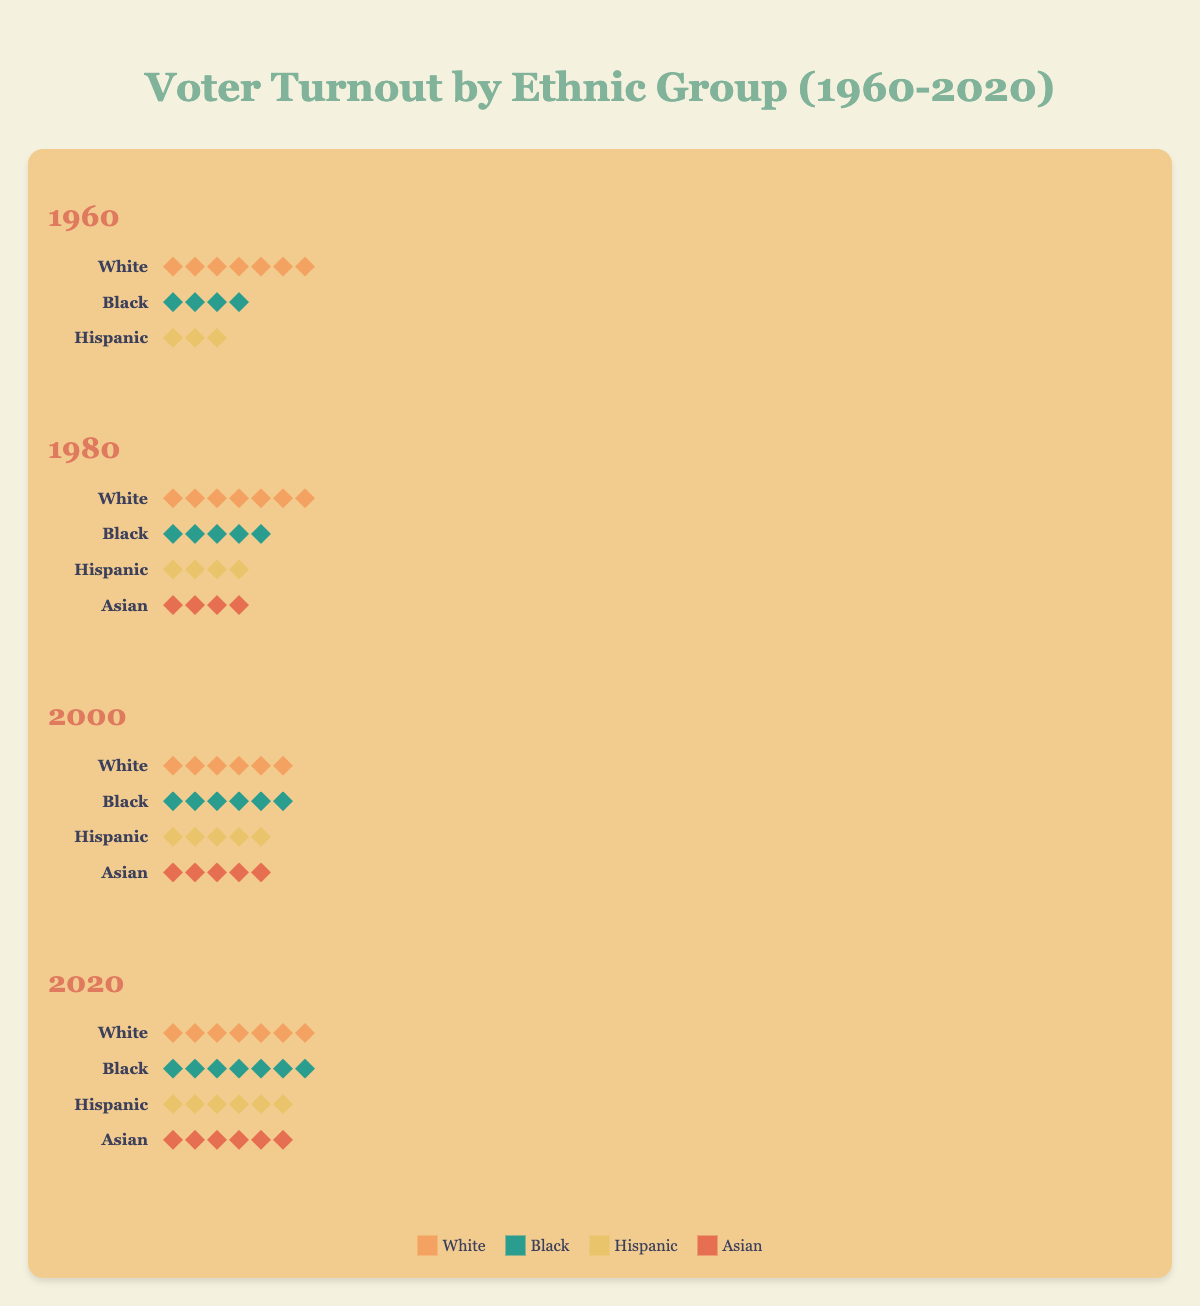What is the overall trend of voter turnout for the White group from 1960 to 2020? The voter turnout for the White group starts at 70% in 1960, decreases to 65% in 1980 and further down to 60% in 2000, then increases back to 70% in 2020.
Answer: Fluctuating with a final increase Which ethnic group had the lowest voter turnout in 1960? By looking at the number of icons representing votes in 1960, the Hispanic group had the lowest turnout with only 3 icons representing 30%.
Answer: Hispanic How many percentage points did the voter turnout for the Black group increase from 1980 to 2020? The turnout increased from 50% in 1980 to 65% in 2020. Calculating the difference: 65% - 50% = 15%.
Answer: 15% What is the difference in voter turnout between the Hispanic and Asian groups in 2020? In 2020, Hispanic turnout was 55% and Asian turnout was 60%. The difference is 60% - 55% = 5%.
Answer: 5% Which group had the highest voter turnout in 2000? Observing the icons for 2000, the White group had the highest turnout with 60% reflected through 6 icons.
Answer: White How did the voter turnout for the Black group change from 1960 to 2000? The Black group’s turnout increased from 40% in 1960 to 50% in 1980 and then further to 55% in 2000.
Answer: Increased How much did the Hispanic voter turnout increase from 1960 to 2020 in terms of percentage? The turnout for Hispanic voters was 30% in 1960 and rose to 55% in 2020. Calculating the increase: 55% - 30% = 25%.
Answer: 25% In which election year did the Asian group first appear, and what was their turnout? The Asian group first appeared in the 1980 election with a voter turnout rate of 40%.
Answer: 1980, 40% What's the total percentage of voter turnout combined for the Asian and Hispanic groups in 2000? Adding the turnout percentages for the Asian (45%) and Hispanic (45%) groups in 2000, we get a total of 45% + 45% = 90%.
Answer: 90% Which group made the most significant gain in voter turnout from 1960 to 2020? By analyzing the changes, the Black group’s turnout increased significantly from 40% in 1960 to 65% in 2020, a gain of 25 percentage points.
Answer: Black 